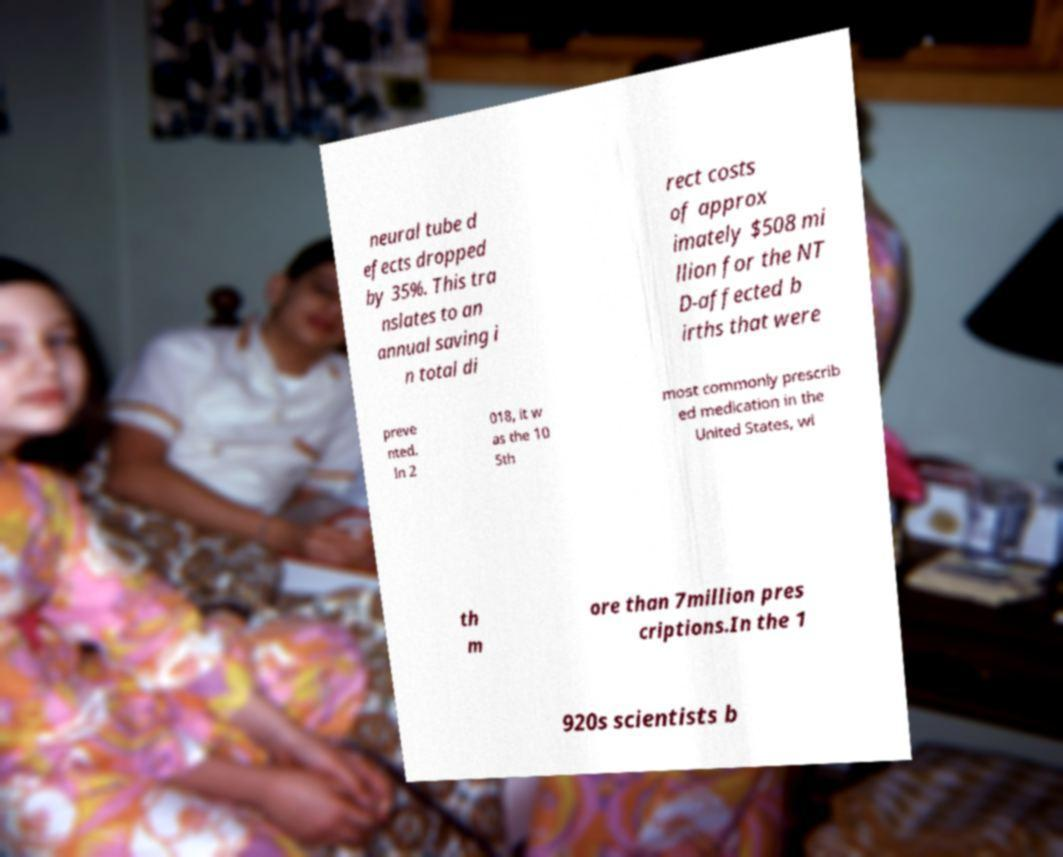Could you assist in decoding the text presented in this image and type it out clearly? neural tube d efects dropped by 35%. This tra nslates to an annual saving i n total di rect costs of approx imately $508 mi llion for the NT D-affected b irths that were preve nted. In 2 018, it w as the 10 5th most commonly prescrib ed medication in the United States, wi th m ore than 7million pres criptions.In the 1 920s scientists b 